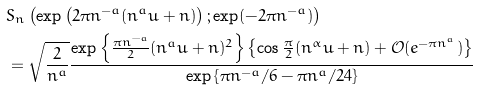Convert formula to latex. <formula><loc_0><loc_0><loc_500><loc_500>& S _ { n } \left ( \exp \left ( 2 \pi n ^ { - a } ( n ^ { a } u + n ) \right ) ; \exp ( - 2 \pi n ^ { - a } ) \right ) \\ & = \sqrt { \frac { 2 } { n ^ { a } } } \frac { \exp \left \{ \frac { \pi n ^ { - a } } { 2 } ( n ^ { a } u + n ) ^ { 2 } \right \} \left \{ \cos \frac { \pi } { 2 } ( n ^ { \alpha } u + n ) + \mathcal { O } ( e ^ { - \pi n ^ { a } } ) \right \} } { \exp \left \{ \pi n ^ { - a } / 6 - \pi n ^ { a } / 2 4 \right \} }</formula> 